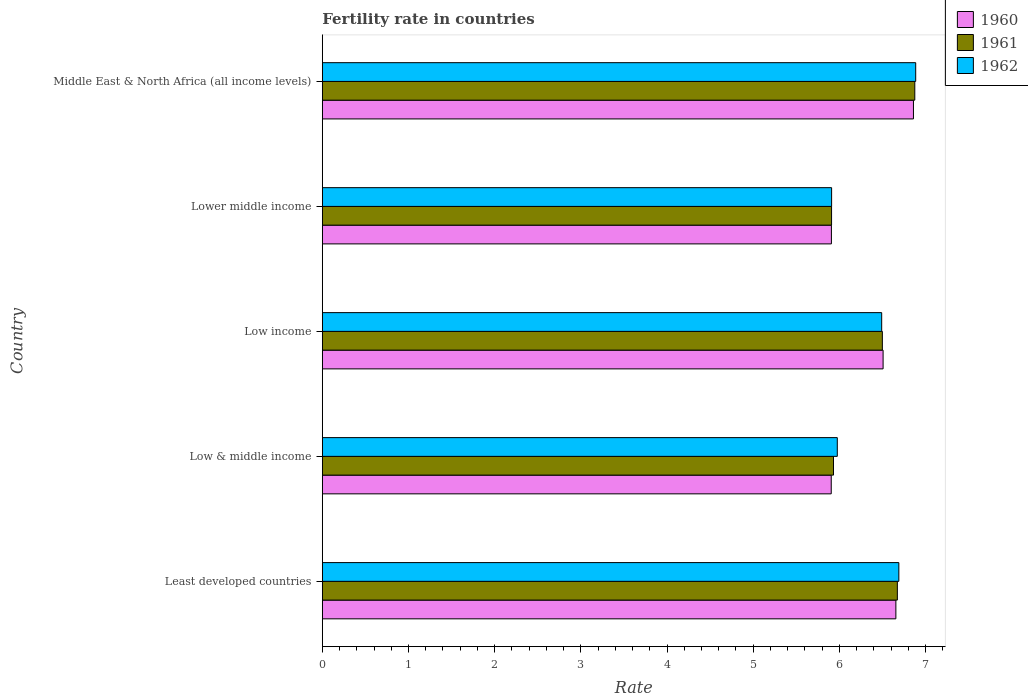How many different coloured bars are there?
Your answer should be very brief. 3. Are the number of bars on each tick of the Y-axis equal?
Your answer should be compact. Yes. How many bars are there on the 4th tick from the bottom?
Provide a short and direct response. 3. What is the label of the 4th group of bars from the top?
Provide a succinct answer. Low & middle income. What is the fertility rate in 1960 in Least developed countries?
Ensure brevity in your answer.  6.66. Across all countries, what is the maximum fertility rate in 1962?
Offer a very short reply. 6.89. Across all countries, what is the minimum fertility rate in 1960?
Keep it short and to the point. 5.91. In which country was the fertility rate in 1961 maximum?
Ensure brevity in your answer.  Middle East & North Africa (all income levels). In which country was the fertility rate in 1962 minimum?
Give a very brief answer. Lower middle income. What is the total fertility rate in 1960 in the graph?
Ensure brevity in your answer.  31.84. What is the difference between the fertility rate in 1960 in Low income and that in Middle East & North Africa (all income levels)?
Make the answer very short. -0.35. What is the difference between the fertility rate in 1961 in Lower middle income and the fertility rate in 1962 in Middle East & North Africa (all income levels)?
Make the answer very short. -0.98. What is the average fertility rate in 1961 per country?
Offer a terse response. 6.38. What is the difference between the fertility rate in 1960 and fertility rate in 1962 in Least developed countries?
Offer a terse response. -0.03. In how many countries, is the fertility rate in 1961 greater than 0.4 ?
Provide a succinct answer. 5. What is the ratio of the fertility rate in 1961 in Low income to that in Middle East & North Africa (all income levels)?
Your answer should be very brief. 0.95. Is the fertility rate in 1960 in Low income less than that in Middle East & North Africa (all income levels)?
Provide a succinct answer. Yes. What is the difference between the highest and the second highest fertility rate in 1960?
Ensure brevity in your answer.  0.2. What is the difference between the highest and the lowest fertility rate in 1961?
Your response must be concise. 0.97. In how many countries, is the fertility rate in 1962 greater than the average fertility rate in 1962 taken over all countries?
Your answer should be very brief. 3. What does the 1st bar from the top in Low income represents?
Give a very brief answer. 1962. Is it the case that in every country, the sum of the fertility rate in 1960 and fertility rate in 1962 is greater than the fertility rate in 1961?
Keep it short and to the point. Yes. How many bars are there?
Ensure brevity in your answer.  15. Are all the bars in the graph horizontal?
Your response must be concise. Yes. What is the difference between two consecutive major ticks on the X-axis?
Offer a very short reply. 1. Does the graph contain any zero values?
Your answer should be compact. No. How many legend labels are there?
Your answer should be very brief. 3. What is the title of the graph?
Provide a succinct answer. Fertility rate in countries. What is the label or title of the X-axis?
Your answer should be very brief. Rate. What is the label or title of the Y-axis?
Give a very brief answer. Country. What is the Rate of 1960 in Least developed countries?
Offer a very short reply. 6.66. What is the Rate in 1961 in Least developed countries?
Provide a succinct answer. 6.67. What is the Rate in 1962 in Least developed countries?
Provide a succinct answer. 6.69. What is the Rate in 1960 in Low & middle income?
Ensure brevity in your answer.  5.91. What is the Rate of 1961 in Low & middle income?
Keep it short and to the point. 5.93. What is the Rate in 1962 in Low & middle income?
Make the answer very short. 5.98. What is the Rate of 1960 in Low income?
Offer a very short reply. 6.51. What is the Rate of 1961 in Low income?
Offer a terse response. 6.5. What is the Rate in 1962 in Low income?
Give a very brief answer. 6.49. What is the Rate in 1960 in Lower middle income?
Make the answer very short. 5.91. What is the Rate in 1961 in Lower middle income?
Your answer should be very brief. 5.91. What is the Rate of 1962 in Lower middle income?
Your answer should be very brief. 5.91. What is the Rate of 1960 in Middle East & North Africa (all income levels)?
Ensure brevity in your answer.  6.86. What is the Rate in 1961 in Middle East & North Africa (all income levels)?
Offer a very short reply. 6.88. What is the Rate of 1962 in Middle East & North Africa (all income levels)?
Keep it short and to the point. 6.89. Across all countries, what is the maximum Rate of 1960?
Offer a very short reply. 6.86. Across all countries, what is the maximum Rate in 1961?
Your answer should be very brief. 6.88. Across all countries, what is the maximum Rate in 1962?
Ensure brevity in your answer.  6.89. Across all countries, what is the minimum Rate in 1960?
Your answer should be very brief. 5.91. Across all countries, what is the minimum Rate in 1961?
Give a very brief answer. 5.91. Across all countries, what is the minimum Rate in 1962?
Your answer should be compact. 5.91. What is the total Rate in 1960 in the graph?
Provide a succinct answer. 31.84. What is the total Rate in 1961 in the graph?
Your answer should be very brief. 31.89. What is the total Rate in 1962 in the graph?
Make the answer very short. 31.95. What is the difference between the Rate in 1960 in Least developed countries and that in Low & middle income?
Ensure brevity in your answer.  0.75. What is the difference between the Rate in 1961 in Least developed countries and that in Low & middle income?
Make the answer very short. 0.74. What is the difference between the Rate in 1962 in Least developed countries and that in Low & middle income?
Give a very brief answer. 0.71. What is the difference between the Rate of 1960 in Least developed countries and that in Low income?
Ensure brevity in your answer.  0.15. What is the difference between the Rate of 1961 in Least developed countries and that in Low income?
Your response must be concise. 0.17. What is the difference between the Rate of 1962 in Least developed countries and that in Low income?
Provide a succinct answer. 0.2. What is the difference between the Rate in 1960 in Least developed countries and that in Lower middle income?
Your response must be concise. 0.75. What is the difference between the Rate of 1961 in Least developed countries and that in Lower middle income?
Offer a terse response. 0.76. What is the difference between the Rate of 1962 in Least developed countries and that in Lower middle income?
Ensure brevity in your answer.  0.78. What is the difference between the Rate of 1960 in Least developed countries and that in Middle East & North Africa (all income levels)?
Provide a short and direct response. -0.2. What is the difference between the Rate of 1961 in Least developed countries and that in Middle East & North Africa (all income levels)?
Your response must be concise. -0.2. What is the difference between the Rate in 1962 in Least developed countries and that in Middle East & North Africa (all income levels)?
Provide a succinct answer. -0.2. What is the difference between the Rate of 1960 in Low & middle income and that in Low income?
Ensure brevity in your answer.  -0.6. What is the difference between the Rate of 1961 in Low & middle income and that in Low income?
Your response must be concise. -0.57. What is the difference between the Rate in 1962 in Low & middle income and that in Low income?
Ensure brevity in your answer.  -0.52. What is the difference between the Rate of 1960 in Low & middle income and that in Lower middle income?
Offer a very short reply. -0. What is the difference between the Rate of 1961 in Low & middle income and that in Lower middle income?
Provide a short and direct response. 0.02. What is the difference between the Rate of 1962 in Low & middle income and that in Lower middle income?
Ensure brevity in your answer.  0.07. What is the difference between the Rate in 1960 in Low & middle income and that in Middle East & North Africa (all income levels)?
Keep it short and to the point. -0.95. What is the difference between the Rate in 1961 in Low & middle income and that in Middle East & North Africa (all income levels)?
Ensure brevity in your answer.  -0.94. What is the difference between the Rate of 1962 in Low & middle income and that in Middle East & North Africa (all income levels)?
Offer a terse response. -0.91. What is the difference between the Rate in 1960 in Low income and that in Lower middle income?
Make the answer very short. 0.6. What is the difference between the Rate in 1961 in Low income and that in Lower middle income?
Offer a very short reply. 0.59. What is the difference between the Rate in 1962 in Low income and that in Lower middle income?
Provide a succinct answer. 0.58. What is the difference between the Rate of 1960 in Low income and that in Middle East & North Africa (all income levels)?
Your response must be concise. -0.35. What is the difference between the Rate of 1961 in Low income and that in Middle East & North Africa (all income levels)?
Your response must be concise. -0.38. What is the difference between the Rate of 1962 in Low income and that in Middle East & North Africa (all income levels)?
Your answer should be compact. -0.39. What is the difference between the Rate of 1960 in Lower middle income and that in Middle East & North Africa (all income levels)?
Make the answer very short. -0.95. What is the difference between the Rate in 1961 in Lower middle income and that in Middle East & North Africa (all income levels)?
Your response must be concise. -0.97. What is the difference between the Rate in 1962 in Lower middle income and that in Middle East & North Africa (all income levels)?
Ensure brevity in your answer.  -0.98. What is the difference between the Rate in 1960 in Least developed countries and the Rate in 1961 in Low & middle income?
Offer a terse response. 0.72. What is the difference between the Rate of 1960 in Least developed countries and the Rate of 1962 in Low & middle income?
Ensure brevity in your answer.  0.68. What is the difference between the Rate of 1961 in Least developed countries and the Rate of 1962 in Low & middle income?
Your answer should be compact. 0.7. What is the difference between the Rate in 1960 in Least developed countries and the Rate in 1961 in Low income?
Your answer should be compact. 0.16. What is the difference between the Rate of 1960 in Least developed countries and the Rate of 1962 in Low income?
Provide a succinct answer. 0.16. What is the difference between the Rate of 1961 in Least developed countries and the Rate of 1962 in Low income?
Make the answer very short. 0.18. What is the difference between the Rate in 1960 in Least developed countries and the Rate in 1961 in Lower middle income?
Provide a succinct answer. 0.75. What is the difference between the Rate of 1960 in Least developed countries and the Rate of 1962 in Lower middle income?
Give a very brief answer. 0.75. What is the difference between the Rate of 1961 in Least developed countries and the Rate of 1962 in Lower middle income?
Ensure brevity in your answer.  0.76. What is the difference between the Rate in 1960 in Least developed countries and the Rate in 1961 in Middle East & North Africa (all income levels)?
Keep it short and to the point. -0.22. What is the difference between the Rate in 1960 in Least developed countries and the Rate in 1962 in Middle East & North Africa (all income levels)?
Your answer should be compact. -0.23. What is the difference between the Rate of 1961 in Least developed countries and the Rate of 1962 in Middle East & North Africa (all income levels)?
Offer a very short reply. -0.21. What is the difference between the Rate in 1960 in Low & middle income and the Rate in 1961 in Low income?
Give a very brief answer. -0.59. What is the difference between the Rate of 1960 in Low & middle income and the Rate of 1962 in Low income?
Your answer should be very brief. -0.59. What is the difference between the Rate of 1961 in Low & middle income and the Rate of 1962 in Low income?
Your answer should be compact. -0.56. What is the difference between the Rate of 1960 in Low & middle income and the Rate of 1961 in Lower middle income?
Offer a terse response. -0. What is the difference between the Rate in 1960 in Low & middle income and the Rate in 1962 in Lower middle income?
Ensure brevity in your answer.  -0. What is the difference between the Rate in 1961 in Low & middle income and the Rate in 1962 in Lower middle income?
Give a very brief answer. 0.02. What is the difference between the Rate of 1960 in Low & middle income and the Rate of 1961 in Middle East & North Africa (all income levels)?
Your answer should be compact. -0.97. What is the difference between the Rate in 1960 in Low & middle income and the Rate in 1962 in Middle East & North Africa (all income levels)?
Offer a terse response. -0.98. What is the difference between the Rate in 1961 in Low & middle income and the Rate in 1962 in Middle East & North Africa (all income levels)?
Your answer should be very brief. -0.95. What is the difference between the Rate in 1960 in Low income and the Rate in 1961 in Lower middle income?
Ensure brevity in your answer.  0.6. What is the difference between the Rate in 1960 in Low income and the Rate in 1962 in Lower middle income?
Make the answer very short. 0.6. What is the difference between the Rate of 1961 in Low income and the Rate of 1962 in Lower middle income?
Your response must be concise. 0.59. What is the difference between the Rate of 1960 in Low income and the Rate of 1961 in Middle East & North Africa (all income levels)?
Offer a terse response. -0.37. What is the difference between the Rate in 1960 in Low income and the Rate in 1962 in Middle East & North Africa (all income levels)?
Provide a succinct answer. -0.38. What is the difference between the Rate in 1961 in Low income and the Rate in 1962 in Middle East & North Africa (all income levels)?
Ensure brevity in your answer.  -0.39. What is the difference between the Rate in 1960 in Lower middle income and the Rate in 1961 in Middle East & North Africa (all income levels)?
Make the answer very short. -0.97. What is the difference between the Rate of 1960 in Lower middle income and the Rate of 1962 in Middle East & North Africa (all income levels)?
Your response must be concise. -0.98. What is the difference between the Rate of 1961 in Lower middle income and the Rate of 1962 in Middle East & North Africa (all income levels)?
Make the answer very short. -0.98. What is the average Rate of 1960 per country?
Make the answer very short. 6.37. What is the average Rate of 1961 per country?
Keep it short and to the point. 6.38. What is the average Rate in 1962 per country?
Your answer should be compact. 6.39. What is the difference between the Rate in 1960 and Rate in 1961 in Least developed countries?
Provide a succinct answer. -0.02. What is the difference between the Rate in 1960 and Rate in 1962 in Least developed countries?
Offer a terse response. -0.03. What is the difference between the Rate in 1961 and Rate in 1962 in Least developed countries?
Give a very brief answer. -0.02. What is the difference between the Rate in 1960 and Rate in 1961 in Low & middle income?
Your answer should be compact. -0.03. What is the difference between the Rate of 1960 and Rate of 1962 in Low & middle income?
Give a very brief answer. -0.07. What is the difference between the Rate of 1961 and Rate of 1962 in Low & middle income?
Offer a very short reply. -0.04. What is the difference between the Rate in 1960 and Rate in 1961 in Low income?
Provide a short and direct response. 0.01. What is the difference between the Rate of 1960 and Rate of 1962 in Low income?
Ensure brevity in your answer.  0.02. What is the difference between the Rate of 1961 and Rate of 1962 in Low income?
Ensure brevity in your answer.  0.01. What is the difference between the Rate of 1960 and Rate of 1961 in Lower middle income?
Your response must be concise. -0. What is the difference between the Rate of 1960 and Rate of 1962 in Lower middle income?
Offer a very short reply. -0. What is the difference between the Rate in 1961 and Rate in 1962 in Lower middle income?
Offer a very short reply. -0. What is the difference between the Rate in 1960 and Rate in 1961 in Middle East & North Africa (all income levels)?
Keep it short and to the point. -0.02. What is the difference between the Rate in 1960 and Rate in 1962 in Middle East & North Africa (all income levels)?
Your answer should be very brief. -0.03. What is the difference between the Rate in 1961 and Rate in 1962 in Middle East & North Africa (all income levels)?
Make the answer very short. -0.01. What is the ratio of the Rate in 1960 in Least developed countries to that in Low & middle income?
Give a very brief answer. 1.13. What is the ratio of the Rate in 1961 in Least developed countries to that in Low & middle income?
Provide a succinct answer. 1.12. What is the ratio of the Rate in 1962 in Least developed countries to that in Low & middle income?
Offer a terse response. 1.12. What is the ratio of the Rate of 1960 in Least developed countries to that in Low income?
Keep it short and to the point. 1.02. What is the ratio of the Rate of 1961 in Least developed countries to that in Low income?
Provide a succinct answer. 1.03. What is the ratio of the Rate in 1962 in Least developed countries to that in Low income?
Your response must be concise. 1.03. What is the ratio of the Rate in 1960 in Least developed countries to that in Lower middle income?
Offer a terse response. 1.13. What is the ratio of the Rate of 1961 in Least developed countries to that in Lower middle income?
Your answer should be compact. 1.13. What is the ratio of the Rate of 1962 in Least developed countries to that in Lower middle income?
Provide a succinct answer. 1.13. What is the ratio of the Rate in 1960 in Least developed countries to that in Middle East & North Africa (all income levels)?
Keep it short and to the point. 0.97. What is the ratio of the Rate of 1961 in Least developed countries to that in Middle East & North Africa (all income levels)?
Ensure brevity in your answer.  0.97. What is the ratio of the Rate in 1962 in Least developed countries to that in Middle East & North Africa (all income levels)?
Your response must be concise. 0.97. What is the ratio of the Rate in 1960 in Low & middle income to that in Low income?
Offer a terse response. 0.91. What is the ratio of the Rate of 1961 in Low & middle income to that in Low income?
Keep it short and to the point. 0.91. What is the ratio of the Rate in 1962 in Low & middle income to that in Low income?
Keep it short and to the point. 0.92. What is the ratio of the Rate of 1960 in Low & middle income to that in Lower middle income?
Your answer should be compact. 1. What is the ratio of the Rate of 1961 in Low & middle income to that in Lower middle income?
Your answer should be very brief. 1. What is the ratio of the Rate of 1962 in Low & middle income to that in Lower middle income?
Offer a very short reply. 1.01. What is the ratio of the Rate in 1960 in Low & middle income to that in Middle East & North Africa (all income levels)?
Your response must be concise. 0.86. What is the ratio of the Rate of 1961 in Low & middle income to that in Middle East & North Africa (all income levels)?
Make the answer very short. 0.86. What is the ratio of the Rate of 1962 in Low & middle income to that in Middle East & North Africa (all income levels)?
Provide a short and direct response. 0.87. What is the ratio of the Rate of 1960 in Low income to that in Lower middle income?
Make the answer very short. 1.1. What is the ratio of the Rate of 1961 in Low income to that in Lower middle income?
Give a very brief answer. 1.1. What is the ratio of the Rate of 1962 in Low income to that in Lower middle income?
Offer a terse response. 1.1. What is the ratio of the Rate in 1960 in Low income to that in Middle East & North Africa (all income levels)?
Your response must be concise. 0.95. What is the ratio of the Rate in 1961 in Low income to that in Middle East & North Africa (all income levels)?
Give a very brief answer. 0.95. What is the ratio of the Rate in 1962 in Low income to that in Middle East & North Africa (all income levels)?
Offer a very short reply. 0.94. What is the ratio of the Rate in 1960 in Lower middle income to that in Middle East & North Africa (all income levels)?
Your answer should be compact. 0.86. What is the ratio of the Rate in 1961 in Lower middle income to that in Middle East & North Africa (all income levels)?
Make the answer very short. 0.86. What is the ratio of the Rate of 1962 in Lower middle income to that in Middle East & North Africa (all income levels)?
Offer a terse response. 0.86. What is the difference between the highest and the second highest Rate of 1960?
Your answer should be compact. 0.2. What is the difference between the highest and the second highest Rate in 1961?
Make the answer very short. 0.2. What is the difference between the highest and the second highest Rate in 1962?
Your response must be concise. 0.2. What is the difference between the highest and the lowest Rate in 1960?
Your response must be concise. 0.95. What is the difference between the highest and the lowest Rate in 1961?
Ensure brevity in your answer.  0.97. What is the difference between the highest and the lowest Rate of 1962?
Provide a short and direct response. 0.98. 